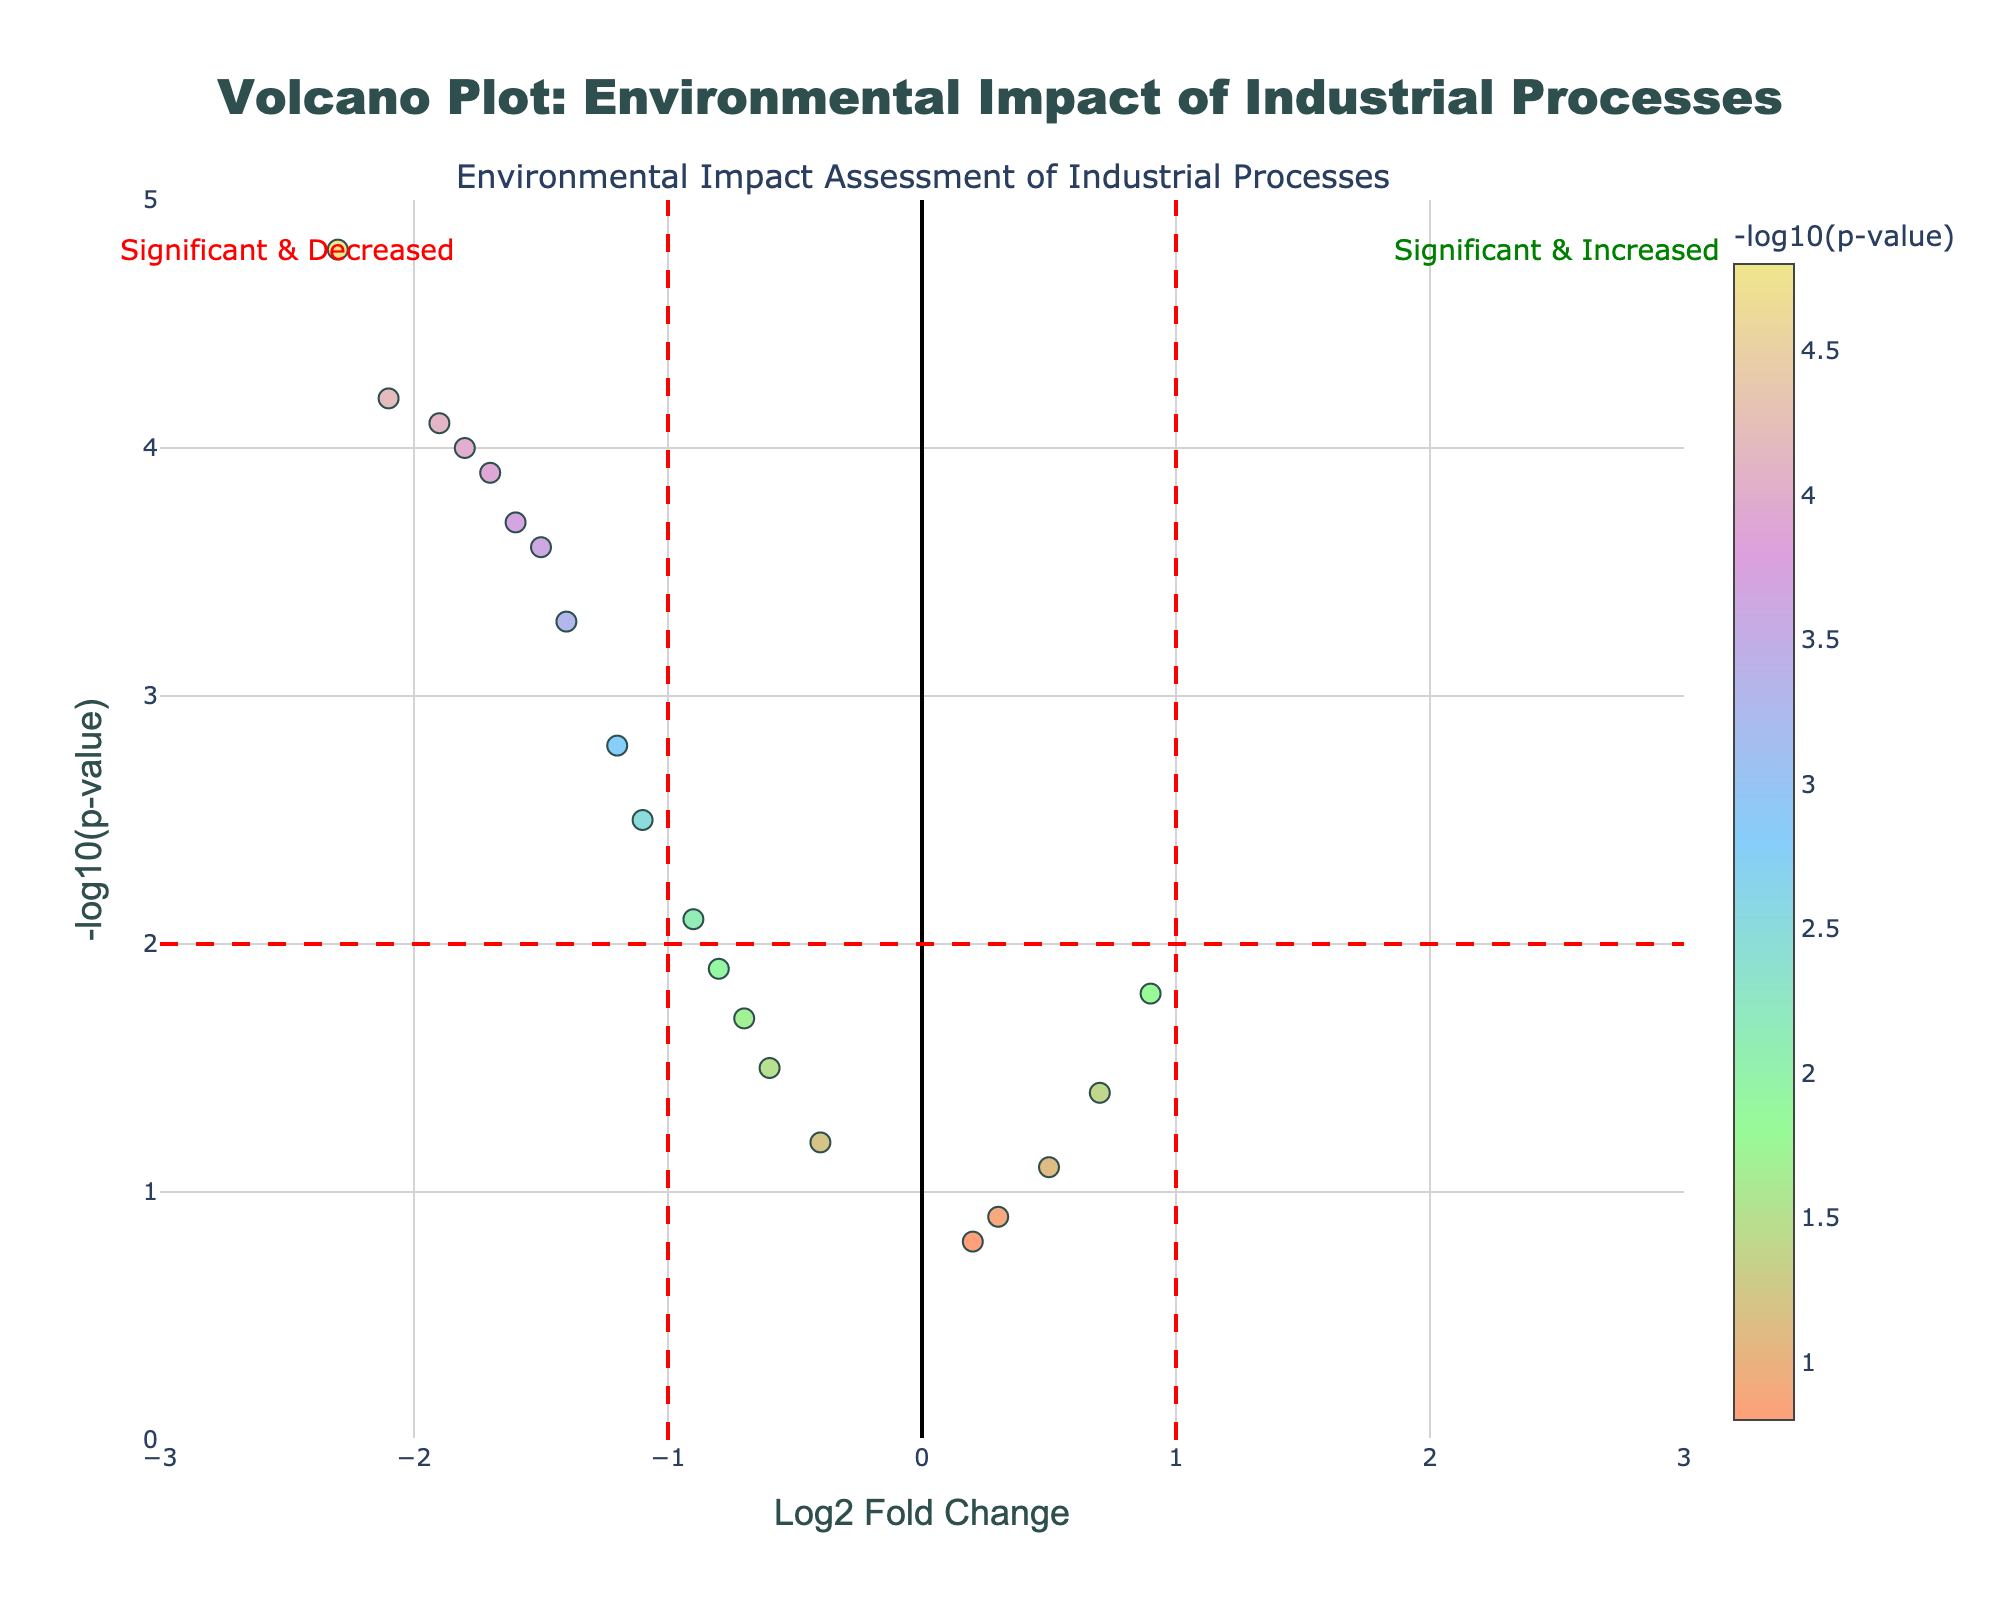What is the title of the plot? The title of the plot is clearly indicated at the top center of the figure. It reads "Volcano Plot: Environmental Impact of Industrial Processes".
Answer: Volcano Plot: Environmental Impact of Industrial Processes How many industrial processes surpass the significant threshold? The significant threshold is depicted visually; points are marked as significant if they pass certain vertical and horizontal lines (colored red). By counting the data points above this threshold in the plot, we can determine the total.
Answer: 11 Which industrial process shows the highest negative log2 fold change? The highest negative log2 fold change corresponds to the point farthest to the left on the x-axis (log2 fold change). This point represents the 'Coal Power Plant'.
Answer: Coal Power Plant Between 'Coal Power Plant' and 'Natural Gas Power Plant,' which has a higher –log10(p-value)? By comparing the y-axis positions of these two points, the 'Coal Power Plant' is higher on the y-axis, indicating a higher -log10(p-value).
Answer: Coal Power Plant Which color scale is used for representing the –log10(p-value) in the scatter plot? The color scale for -log10(p-value) is a range of five colors represented visually on the plot's right as a color bar. These colors include light shades like '#FFA07A' (light salmon) to '#F0E68C' (light khaki).
Answer: Light Salmon to Light Khaki How are significant and increased processes visually annotated? The figure contains two annotations: 'Significant & Increased' on the top right and 'Significant & Decreased' on the top left. This indicates differential regulatory thresholds for increased emissions.
Answer: Significant & Increased annotation on the top right What is the log2 fold change threshold for significance? The figure includes two vertical red dashed lines at x = -1 and x = 1. These delineate the log2 fold change thresholds.
Answer: -1 and 1 How many processes fall between -1 and 1 in log2 fold change but are considered insignificant? First, identify points within the -1 to 1 range on the x-axis, then check if they are beneath the horizontal significance threshold (colored red line at y = 2).
Answer: 8 Which process has a log2 fold change close to zero but a relatively high –log10(p-value)? The process near 0 on the x-axis with higher -log10(p-value) can be located visually near the top center. The 'Food Processing' process is relatively high.
Answer: Food Processing Does 'Paper Mill' exceed the significant threshold for either emissions or regulatory levels? By locating the 'Paper Mill' on the plot (hovering dataset or position), it is plotted below the horizontal red line and falls within -1 and 1. Hence, it does not exceed the threshold.
Answer: No 